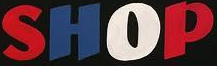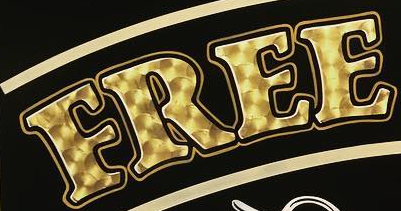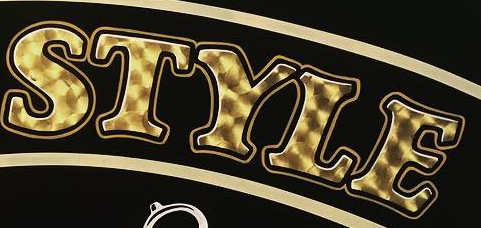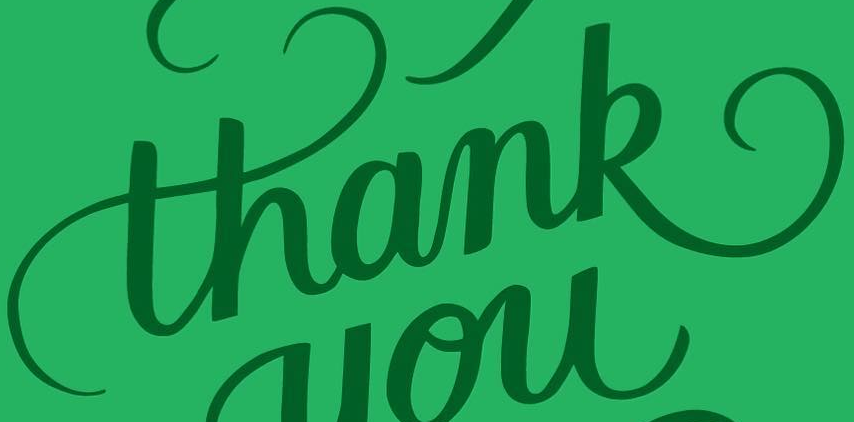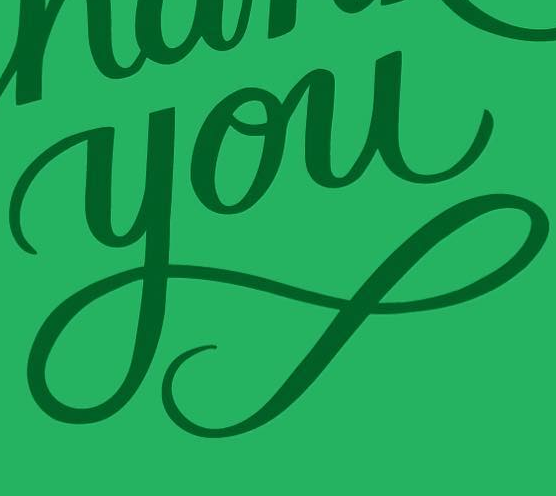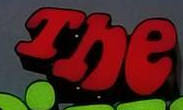Identify the words shown in these images in order, separated by a semicolon. SHOP; FREE; STYLE; thank; you; The 